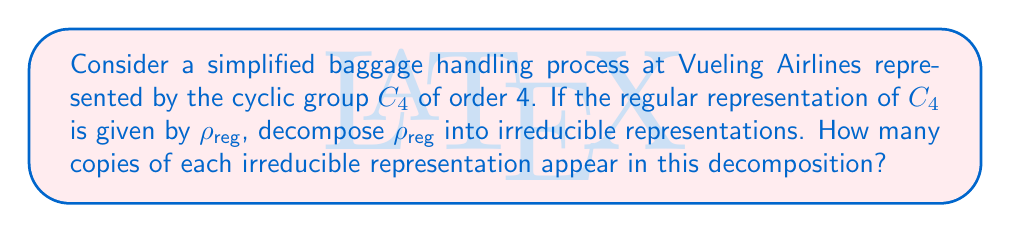Can you answer this question? 1) First, recall that for a cyclic group $C_n$, there are $n$ irreducible representations, each of dimension 1. Let's denote these as $\chi_0, \chi_1, \chi_2, \chi_3$ for $C_4$.

2) The character of the regular representation $\rho_{\text{reg}}$ for any group $G$ is given by:
   $$\chi_{\text{reg}}(g) = \begin{cases} 
   |G| & \text{if } g = e \\
   0 & \text{if } g \neq e
   \end{cases}$$

3) For $C_4$, this means $\chi_{\text{reg}} = (4, 0, 0, 0)$.

4) The irreducible characters of $C_4$ are:
   $\chi_0 = (1, 1, 1, 1)$
   $\chi_1 = (1, i, -1, -i)$
   $\chi_2 = (1, -1, 1, -1)$
   $\chi_3 = (1, -i, -1, i)$

5) To find the multiplicity of each irreducible representation in $\rho_{\text{reg}}$, we use the inner product of characters:
   $$\langle \chi_{\text{reg}}, \chi_j \rangle = \frac{1}{|G|} \sum_{g \in G} \chi_{\text{reg}}(g) \overline{\chi_j(g)}$$

6) Calculating for each $\chi_j$:
   $\langle \chi_{\text{reg}}, \chi_0 \rangle = \frac{1}{4}(4 \cdot 1 + 0 + 0 + 0) = 1$
   $\langle \chi_{\text{reg}}, \chi_1 \rangle = \frac{1}{4}(4 \cdot 1 + 0 + 0 + 0) = 1$
   $\langle \chi_{\text{reg}}, \chi_2 \rangle = \frac{1}{4}(4 \cdot 1 + 0 + 0 + 0) = 1$
   $\langle \chi_{\text{reg}}, \chi_3 \rangle = \frac{1}{4}(4 \cdot 1 + 0 + 0 + 0) = 1$

7) Therefore, $\rho_{\text{reg}} = \chi_0 \oplus \chi_1 \oplus \chi_2 \oplus \chi_3$
Answer: One copy of each irreducible representation 